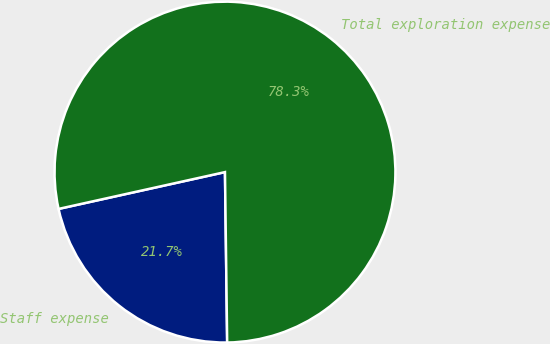Convert chart to OTSL. <chart><loc_0><loc_0><loc_500><loc_500><pie_chart><fcel>Staff expense<fcel>Total exploration expense<nl><fcel>21.74%<fcel>78.26%<nl></chart> 